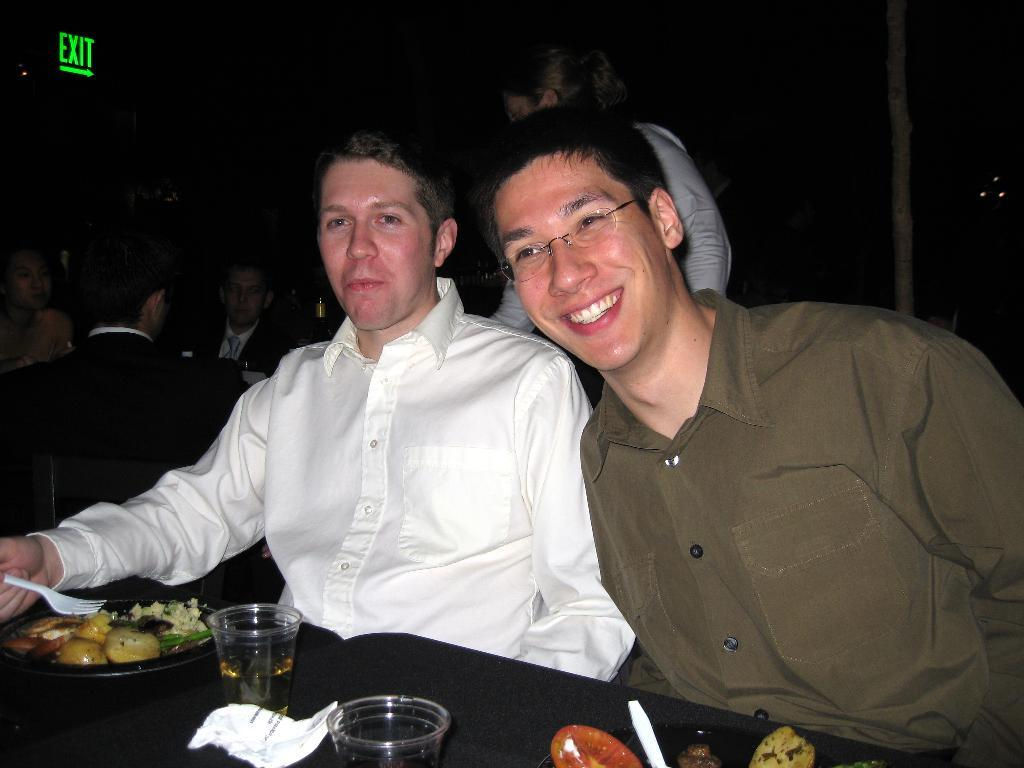How many people are in the image? There are two people in the image. What is the facial expression of the people in the image? Both people are smiling. What can be seen on the table in the image? There are food items on the table. Where are the people sitting in the image? There are people sitting on the left side of the image. What type of alley can be seen in the background of the image? There is no alley present in the image; it features two people sitting at a table with food items. Can you tell me the length of the needle used to sew the people's clothes in the image? There is no needle or mention of sewing in the image; it simply shows two people smiling and sitting at a table with food items. 